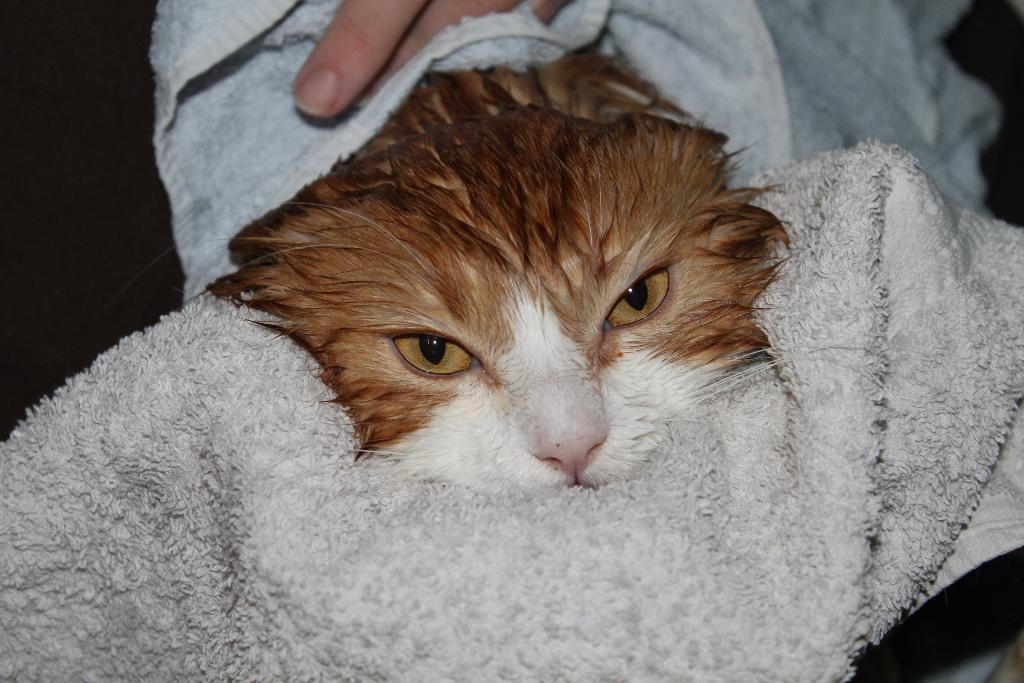What type of animal is in the image? There is a cat in the image. How is the cat positioned or wrapped in the image? The cat is wrapped in a white towel. Whose hand fingers are visible at the bottom of the image? The hand fingers of a person are visible at the bottom of the image. What color is the background of the image? The background of the image is black. What type of watch can be seen on the cat's paw in the image? There is no watch present on the cat's paw in the image. How many flies are visible on the cat in the image? There are no flies visible on the cat in the image. 